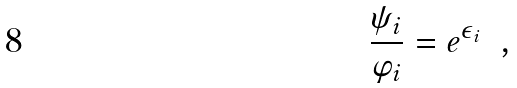<formula> <loc_0><loc_0><loc_500><loc_500>\frac { \psi _ { i } } { \varphi _ { i } } = e ^ { \epsilon _ { i } } \ \ ,</formula> 